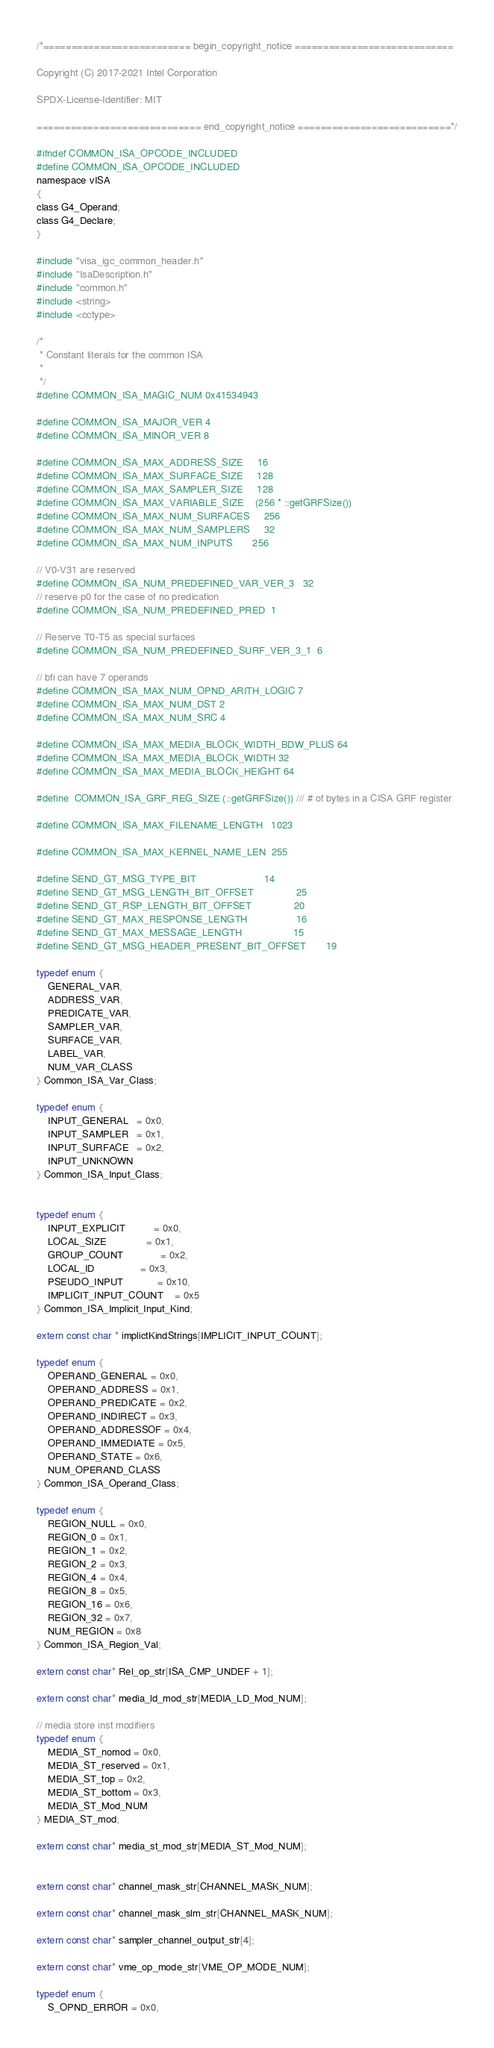Convert code to text. <code><loc_0><loc_0><loc_500><loc_500><_C_>/*========================== begin_copyright_notice ============================

Copyright (C) 2017-2021 Intel Corporation

SPDX-License-Identifier: MIT

============================= end_copyright_notice ===========================*/

#ifndef COMMON_ISA_OPCODE_INCLUDED
#define COMMON_ISA_OPCODE_INCLUDED
namespace vISA
{
class G4_Operand;
class G4_Declare;
}

#include "visa_igc_common_header.h"
#include "IsaDescription.h"
#include "common.h"
#include <string>
#include <cctype>

/*
 * Constant literals for the common ISA
 *
 */
#define COMMON_ISA_MAGIC_NUM 0x41534943

#define COMMON_ISA_MAJOR_VER 4
#define COMMON_ISA_MINOR_VER 8

#define COMMON_ISA_MAX_ADDRESS_SIZE     16
#define COMMON_ISA_MAX_SURFACE_SIZE     128
#define COMMON_ISA_MAX_SAMPLER_SIZE     128
#define COMMON_ISA_MAX_VARIABLE_SIZE    (256 * ::getGRFSize())
#define COMMON_ISA_MAX_NUM_SURFACES     256
#define COMMON_ISA_MAX_NUM_SAMPLERS     32
#define COMMON_ISA_MAX_NUM_INPUTS       256

// V0-V31 are reserved
#define COMMON_ISA_NUM_PREDEFINED_VAR_VER_3   32
// reserve p0 for the case of no predication
#define COMMON_ISA_NUM_PREDEFINED_PRED  1

// Reserve T0-T5 as special surfaces
#define COMMON_ISA_NUM_PREDEFINED_SURF_VER_3_1  6

// bfi can have 7 operands
#define COMMON_ISA_MAX_NUM_OPND_ARITH_LOGIC 7
#define COMMON_ISA_MAX_NUM_DST 2
#define COMMON_ISA_MAX_NUM_SRC 4

#define COMMON_ISA_MAX_MEDIA_BLOCK_WIDTH_BDW_PLUS 64
#define COMMON_ISA_MAX_MEDIA_BLOCK_WIDTH 32
#define COMMON_ISA_MAX_MEDIA_BLOCK_HEIGHT 64

#define  COMMON_ISA_GRF_REG_SIZE (::getGRFSize()) /// # of bytes in a CISA GRF register

#define COMMON_ISA_MAX_FILENAME_LENGTH   1023

#define COMMON_ISA_MAX_KERNEL_NAME_LEN  255

#define SEND_GT_MSG_TYPE_BIT                        14
#define SEND_GT_MSG_LENGTH_BIT_OFFSET               25
#define SEND_GT_RSP_LENGTH_BIT_OFFSET               20
#define SEND_GT_MAX_RESPONSE_LENGTH                 16
#define SEND_GT_MAX_MESSAGE_LENGTH                  15
#define SEND_GT_MSG_HEADER_PRESENT_BIT_OFFSET       19

typedef enum {
    GENERAL_VAR,
    ADDRESS_VAR,
    PREDICATE_VAR,
    SAMPLER_VAR,
    SURFACE_VAR,
    LABEL_VAR,
    NUM_VAR_CLASS
} Common_ISA_Var_Class;

typedef enum {
    INPUT_GENERAL   = 0x0,
    INPUT_SAMPLER   = 0x1,
    INPUT_SURFACE   = 0x2,
    INPUT_UNKNOWN
} Common_ISA_Input_Class;


typedef enum {
    INPUT_EXPLICIT          = 0x0,
    LOCAL_SIZE              = 0x1,
    GROUP_COUNT             = 0x2,
    LOCAL_ID                = 0x3,
    PSEUDO_INPUT            = 0x10,
    IMPLICIT_INPUT_COUNT    = 0x5
} Common_ISA_Implicit_Input_Kind;

extern const char * implictKindStrings[IMPLICIT_INPUT_COUNT];

typedef enum {
    OPERAND_GENERAL = 0x0,
    OPERAND_ADDRESS = 0x1,
    OPERAND_PREDICATE = 0x2,
    OPERAND_INDIRECT = 0x3,
    OPERAND_ADDRESSOF = 0x4,
    OPERAND_IMMEDIATE = 0x5,
    OPERAND_STATE = 0x6,
    NUM_OPERAND_CLASS
} Common_ISA_Operand_Class;

typedef enum {
    REGION_NULL = 0x0,
    REGION_0 = 0x1,
    REGION_1 = 0x2,
    REGION_2 = 0x3,
    REGION_4 = 0x4,
    REGION_8 = 0x5,
    REGION_16 = 0x6,
    REGION_32 = 0x7,
    NUM_REGION = 0x8
} Common_ISA_Region_Val;

extern const char* Rel_op_str[ISA_CMP_UNDEF + 1];

extern const char* media_ld_mod_str[MEDIA_LD_Mod_NUM];

// media store inst modifiers
typedef enum {
    MEDIA_ST_nomod = 0x0,
    MEDIA_ST_reserved = 0x1,
    MEDIA_ST_top = 0x2,
    MEDIA_ST_bottom = 0x3,
    MEDIA_ST_Mod_NUM
} MEDIA_ST_mod;

extern const char* media_st_mod_str[MEDIA_ST_Mod_NUM];


extern const char* channel_mask_str[CHANNEL_MASK_NUM];

extern const char* channel_mask_slm_str[CHANNEL_MASK_NUM];

extern const char* sampler_channel_output_str[4];

extern const char* vme_op_mode_str[VME_OP_MODE_NUM];

typedef enum {
    S_OPND_ERROR = 0x0,</code> 